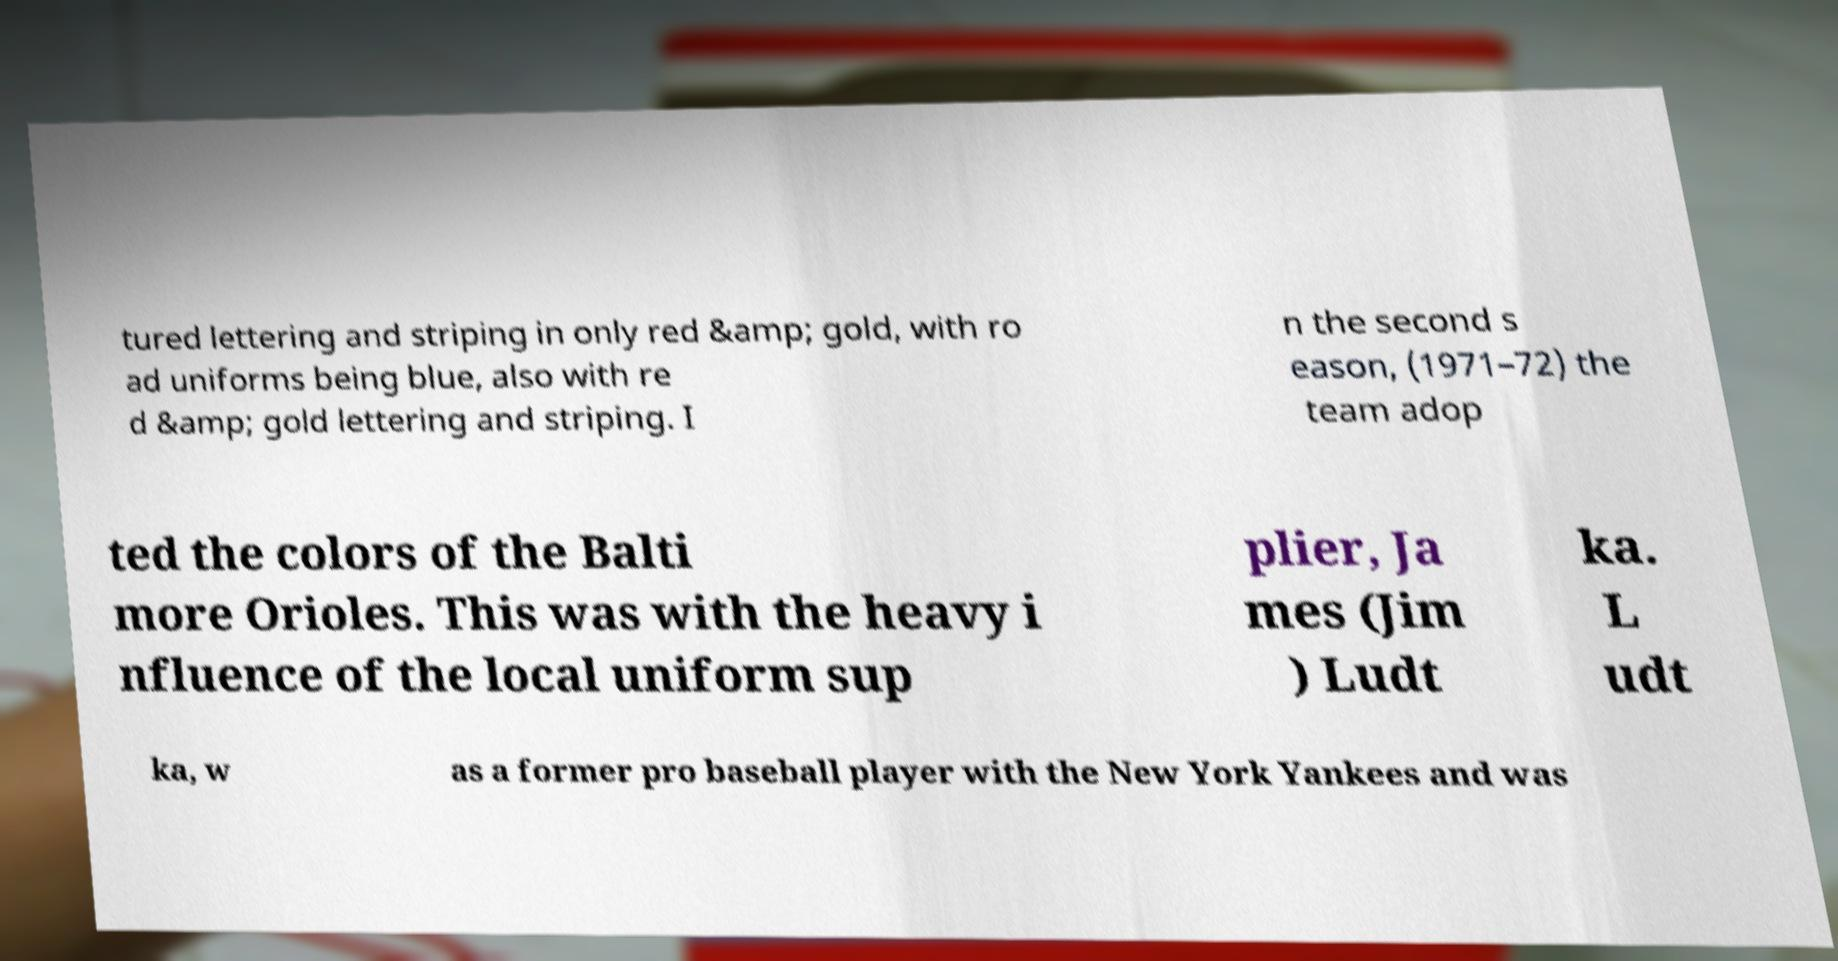For documentation purposes, I need the text within this image transcribed. Could you provide that? tured lettering and striping in only red &amp; gold, with ro ad uniforms being blue, also with re d &amp; gold lettering and striping. I n the second s eason, (1971–72) the team adop ted the colors of the Balti more Orioles. This was with the heavy i nfluence of the local uniform sup plier, Ja mes (Jim ) Ludt ka. L udt ka, w as a former pro baseball player with the New York Yankees and was 